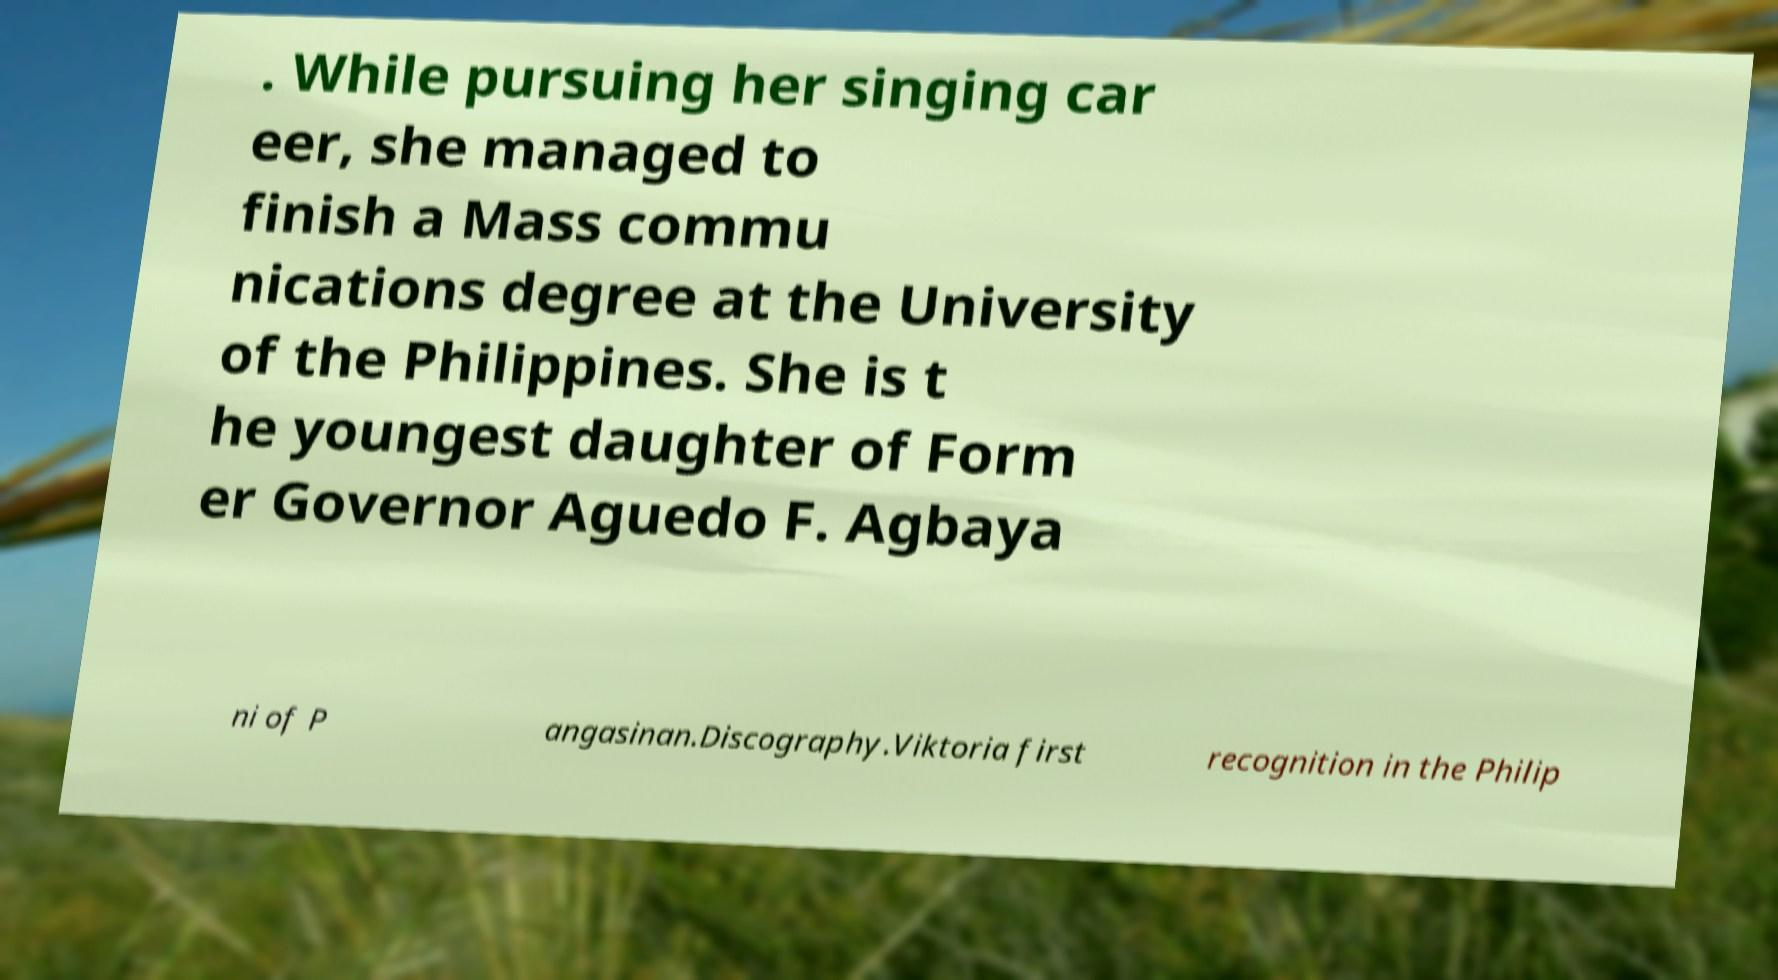For documentation purposes, I need the text within this image transcribed. Could you provide that? . While pursuing her singing car eer, she managed to finish a Mass commu nications degree at the University of the Philippines. She is t he youngest daughter of Form er Governor Aguedo F. Agbaya ni of P angasinan.Discography.Viktoria first recognition in the Philip 